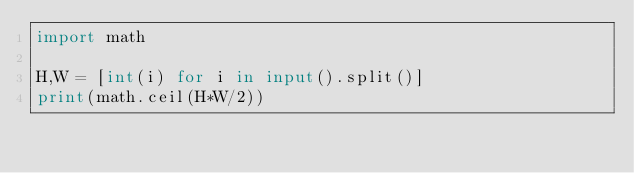Convert code to text. <code><loc_0><loc_0><loc_500><loc_500><_Python_>import math

H,W = [int(i) for i in input().split()]
print(math.ceil(H*W/2))</code> 